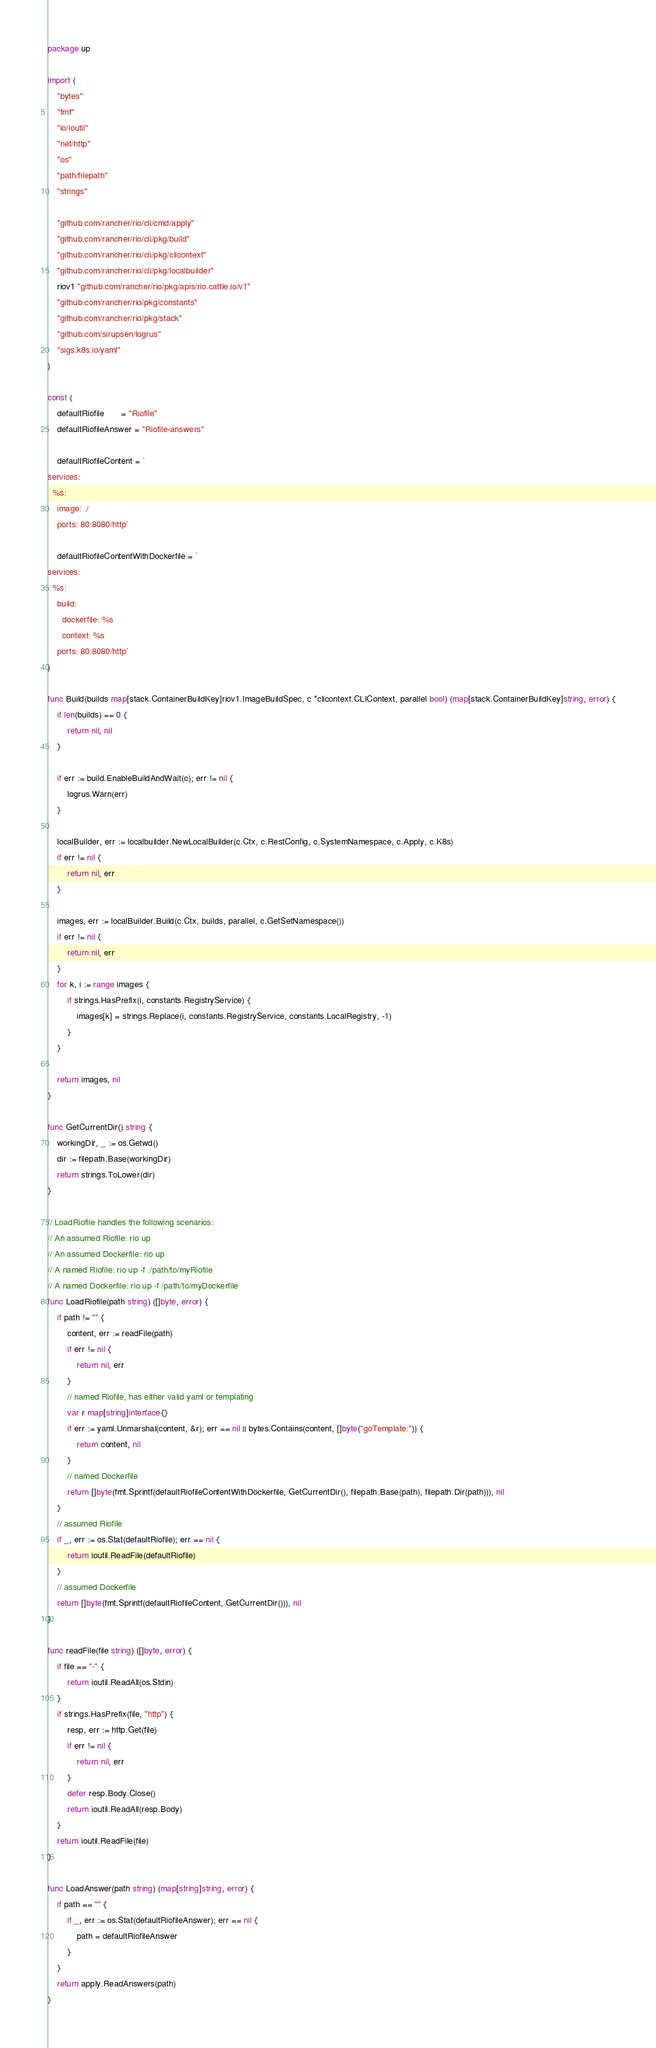Convert code to text. <code><loc_0><loc_0><loc_500><loc_500><_Go_>package up

import (
	"bytes"
	"fmt"
	"io/ioutil"
	"net/http"
	"os"
	"path/filepath"
	"strings"

	"github.com/rancher/rio/cli/cmd/apply"
	"github.com/rancher/rio/cli/pkg/build"
	"github.com/rancher/rio/cli/pkg/clicontext"
	"github.com/rancher/rio/cli/pkg/localbuilder"
	riov1 "github.com/rancher/rio/pkg/apis/rio.cattle.io/v1"
	"github.com/rancher/rio/pkg/constants"
	"github.com/rancher/rio/pkg/stack"
	"github.com/sirupsen/logrus"
	"sigs.k8s.io/yaml"
)

const (
	defaultRiofile       = "Riofile"
	defaultRiofileAnswer = "Riofile-answers"

	defaultRiofileContent = `
services:
  %s:
    image: ./
    ports: 80:8080/http`

	defaultRiofileContentWithDockerfile = `
services:
  %s:
    build:
      dockerfile: %s
      context: %s
    ports: 80:8080/http`
)

func Build(builds map[stack.ContainerBuildKey]riov1.ImageBuildSpec, c *clicontext.CLIContext, parallel bool) (map[stack.ContainerBuildKey]string, error) {
	if len(builds) == 0 {
		return nil, nil
	}

	if err := build.EnableBuildAndWait(c); err != nil {
		logrus.Warn(err)
	}

	localBuilder, err := localbuilder.NewLocalBuilder(c.Ctx, c.RestConfig, c.SystemNamespace, c.Apply, c.K8s)
	if err != nil {
		return nil, err
	}

	images, err := localBuilder.Build(c.Ctx, builds, parallel, c.GetSetNamespace())
	if err != nil {
		return nil, err
	}
	for k, i := range images {
		if strings.HasPrefix(i, constants.RegistryService) {
			images[k] = strings.Replace(i, constants.RegistryService, constants.LocalRegistry, -1)
		}
	}

	return images, nil
}

func GetCurrentDir() string {
	workingDir, _ := os.Getwd()
	dir := filepath.Base(workingDir)
	return strings.ToLower(dir)
}

// LoadRiofile handles the following scenarios:
// An assumed Riofile: rio up
// An assumed Dockerfile: rio up
// A named Riofile: rio up -f ./path/to/myRiofile
// A named Dockerfile: rio up -f /path/to/myDockerfile
func LoadRiofile(path string) ([]byte, error) {
	if path != "" {
		content, err := readFile(path)
		if err != nil {
			return nil, err
		}
		// named Riofile, has either valid yaml or templating
		var r map[string]interface{}
		if err := yaml.Unmarshal(content, &r); err == nil || bytes.Contains(content, []byte("goTemplate:")) {
			return content, nil
		}
		// named Dockerfile
		return []byte(fmt.Sprintf(defaultRiofileContentWithDockerfile, GetCurrentDir(), filepath.Base(path), filepath.Dir(path))), nil
	}
	// assumed Riofile
	if _, err := os.Stat(defaultRiofile); err == nil {
		return ioutil.ReadFile(defaultRiofile)
	}
	// assumed Dockerfile
	return []byte(fmt.Sprintf(defaultRiofileContent, GetCurrentDir())), nil
}

func readFile(file string) ([]byte, error) {
	if file == "-" {
		return ioutil.ReadAll(os.Stdin)
	}
	if strings.HasPrefix(file, "http") {
		resp, err := http.Get(file)
		if err != nil {
			return nil, err
		}
		defer resp.Body.Close()
		return ioutil.ReadAll(resp.Body)
	}
	return ioutil.ReadFile(file)
}

func LoadAnswer(path string) (map[string]string, error) {
	if path == "" {
		if _, err := os.Stat(defaultRiofileAnswer); err == nil {
			path = defaultRiofileAnswer
		}
	}
	return apply.ReadAnswers(path)
}
</code> 